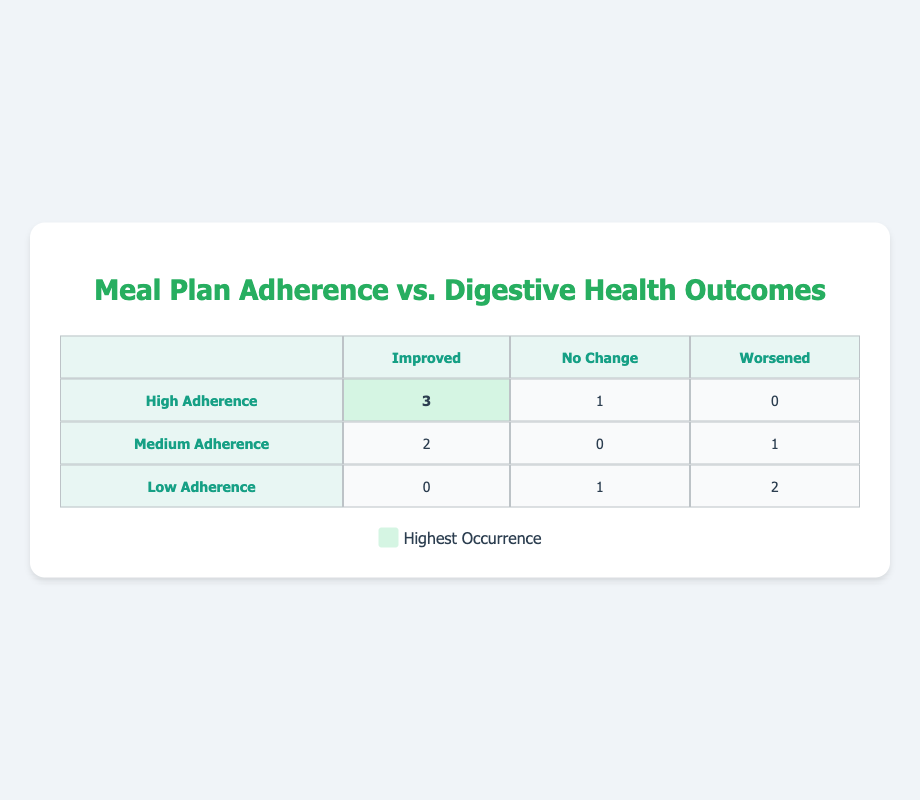What is the number of participants with high adherence whose digestive health improved? From the "High Adherence" row, we can see that the value under "Improved" is 3. This indicates that 3 participants with high adherence reported improvements in their digestive health.
Answer: 3 How many participants in total reported "Worsened" digestive health outcomes? Looking at the table, under the "Worsened" column, we see that there are 1 (Medium Adherence) + 2 (Low Adherence) = 3 participants. Thus, a total of 3 participants reported worsened digestive health outcomes.
Answer: 3 What is the count of participants that reported "No Change" in their digestive health while having medium adherence? Under the "Medium Adherence" row, the value in the "No Change" column is 0. Hence, no participants reported no change in their digestive health among those with medium adherence.
Answer: 0 Is it true that all participants with low adherence reported a worsening of their digestive health? Checking the "Low Adherence" row, we find that there are 2 participants who reported "Worsened" and 1 who said "No Change." Therefore, it is false that all participants with low adherence reported a worsening of their digestive health.
Answer: False What is the average number of improved digestive health outcomes across the three levels of adherence? The total number of improved outcomes is 3 (High) + 2 (Medium) + 0 (Low) = 5. There are 3 categories of adherence, so the average is 5/3, which is approximately 1.67.
Answer: 1.67 How many participants with high adherence reported "No Change" in their digestive health? In the "High Adherence" row under the "No Change" column, the value is 1. Therefore, there is 1 participant with high adherence who reported no change in their digestive health.
Answer: 1 What is the total number of participants categorized under low adherence? The "Low Adherence" row indicates there are 3 entries (1 for "No Change" and 2 for "Worsened"). Thus, the total number of participants under low adherence is 3.
Answer: 3 How does the number of participants reporting improved health compare between high and medium adherence? For "Improved" under "High Adherence," the count is 3, while for "Medium Adherence," it is 2. Therefore, high adherence has 1 more participant reporting improved health than medium adherence.
Answer: 1 more How many participants showed improvement in their digestive health without any change in other outcomes with high adherence? In the "High Adherence" row, there are 3 participants who reported improvement and 1 who reported no change. Thus, 3 participants improved without reporting any other outcomes.
Answer: 3 